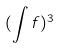Convert formula to latex. <formula><loc_0><loc_0><loc_500><loc_500>( \int f ) ^ { 3 }</formula> 